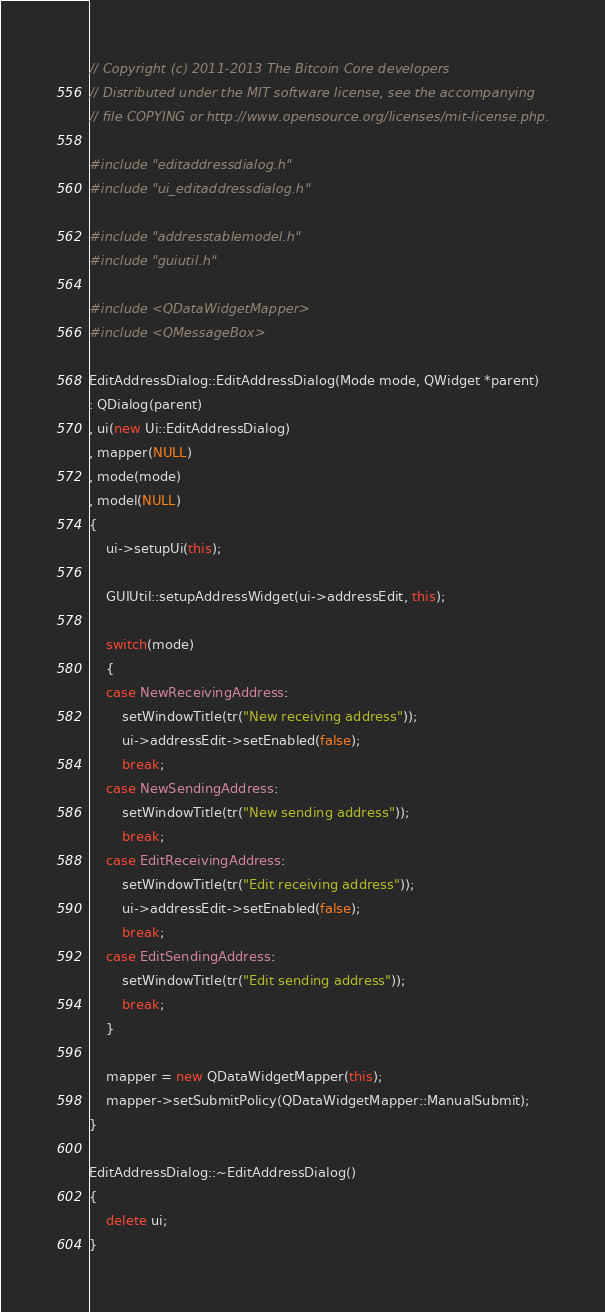Convert code to text. <code><loc_0><loc_0><loc_500><loc_500><_C++_>// Copyright (c) 2011-2013 The Bitcoin Core developers
// Distributed under the MIT software license, see the accompanying
// file COPYING or http://www.opensource.org/licenses/mit-license.php.

#include "editaddressdialog.h"
#include "ui_editaddressdialog.h"

#include "addresstablemodel.h"
#include "guiutil.h"

#include <QDataWidgetMapper>
#include <QMessageBox>

EditAddressDialog::EditAddressDialog(Mode mode, QWidget *parent)
: QDialog(parent)
, ui(new Ui::EditAddressDialog)
, mapper(NULL)
, mode(mode)
, model(NULL)
{
    ui->setupUi(this);

    GUIUtil::setupAddressWidget(ui->addressEdit, this);

    switch(mode)
    {
    case NewReceivingAddress:
        setWindowTitle(tr("New receiving address"));
        ui->addressEdit->setEnabled(false);
        break;
    case NewSendingAddress:
        setWindowTitle(tr("New sending address"));
        break;
    case EditReceivingAddress:
        setWindowTitle(tr("Edit receiving address"));
        ui->addressEdit->setEnabled(false);
        break;
    case EditSendingAddress:
        setWindowTitle(tr("Edit sending address"));
        break;
    }

    mapper = new QDataWidgetMapper(this);
    mapper->setSubmitPolicy(QDataWidgetMapper::ManualSubmit);
}

EditAddressDialog::~EditAddressDialog()
{
    delete ui;
}
</code> 